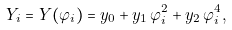Convert formula to latex. <formula><loc_0><loc_0><loc_500><loc_500>Y _ { i } = Y ( \varphi _ { i } ) = y _ { 0 } + y _ { 1 } \, \varphi _ { i } ^ { 2 } + y _ { 2 } \, \varphi _ { i } ^ { 4 } ,</formula> 